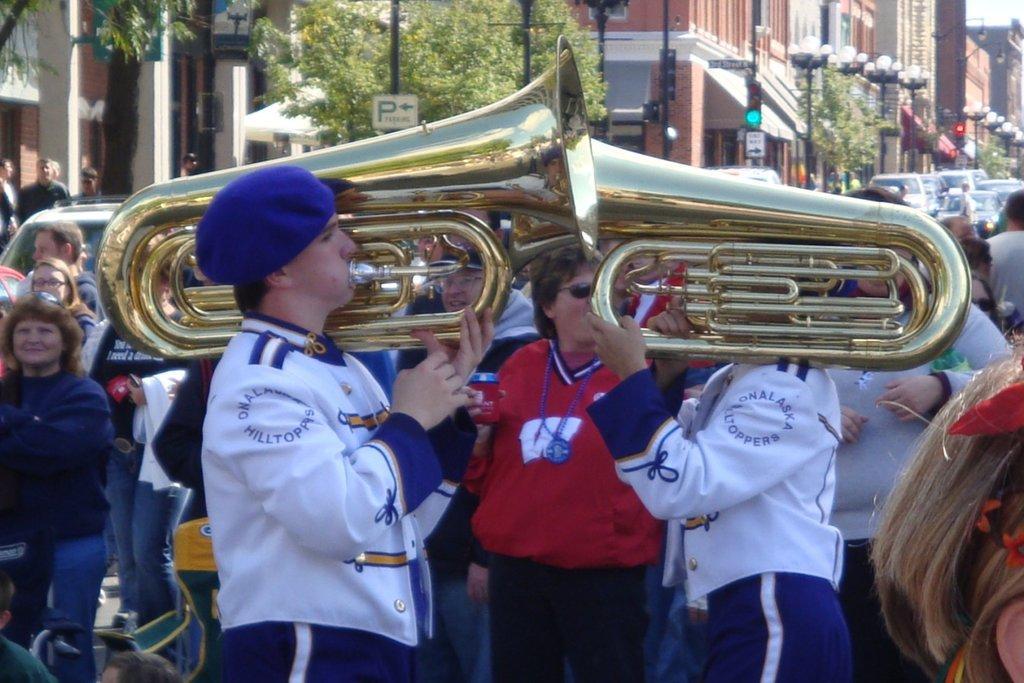Could you give a brief overview of what you see in this image? In this image we can see two persons holding the musical instruments and standing. We can also see the people in the background. Image also consists of trees, buildings, light poles, sign board poles and also the vehicles. 